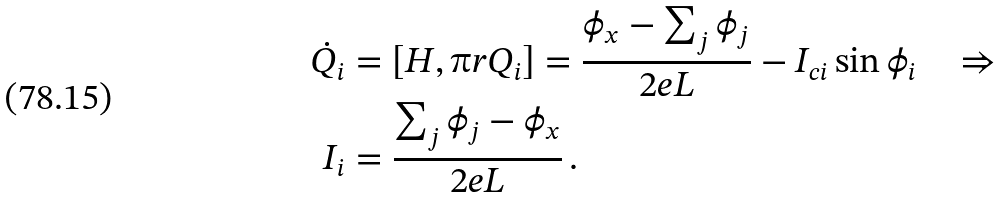<formula> <loc_0><loc_0><loc_500><loc_500>\dot { Q } _ { i } & = [ H , \i r Q _ { i } ] = \frac { \phi _ { x } - \sum _ { j } \phi _ { j } } { 2 e L } - I _ { c i } \sin \phi _ { i } \quad \Rightarrow \\ I _ { i } & = \frac { \sum _ { j } \phi _ { j } - \phi _ { x } } { 2 e L } \, .</formula> 